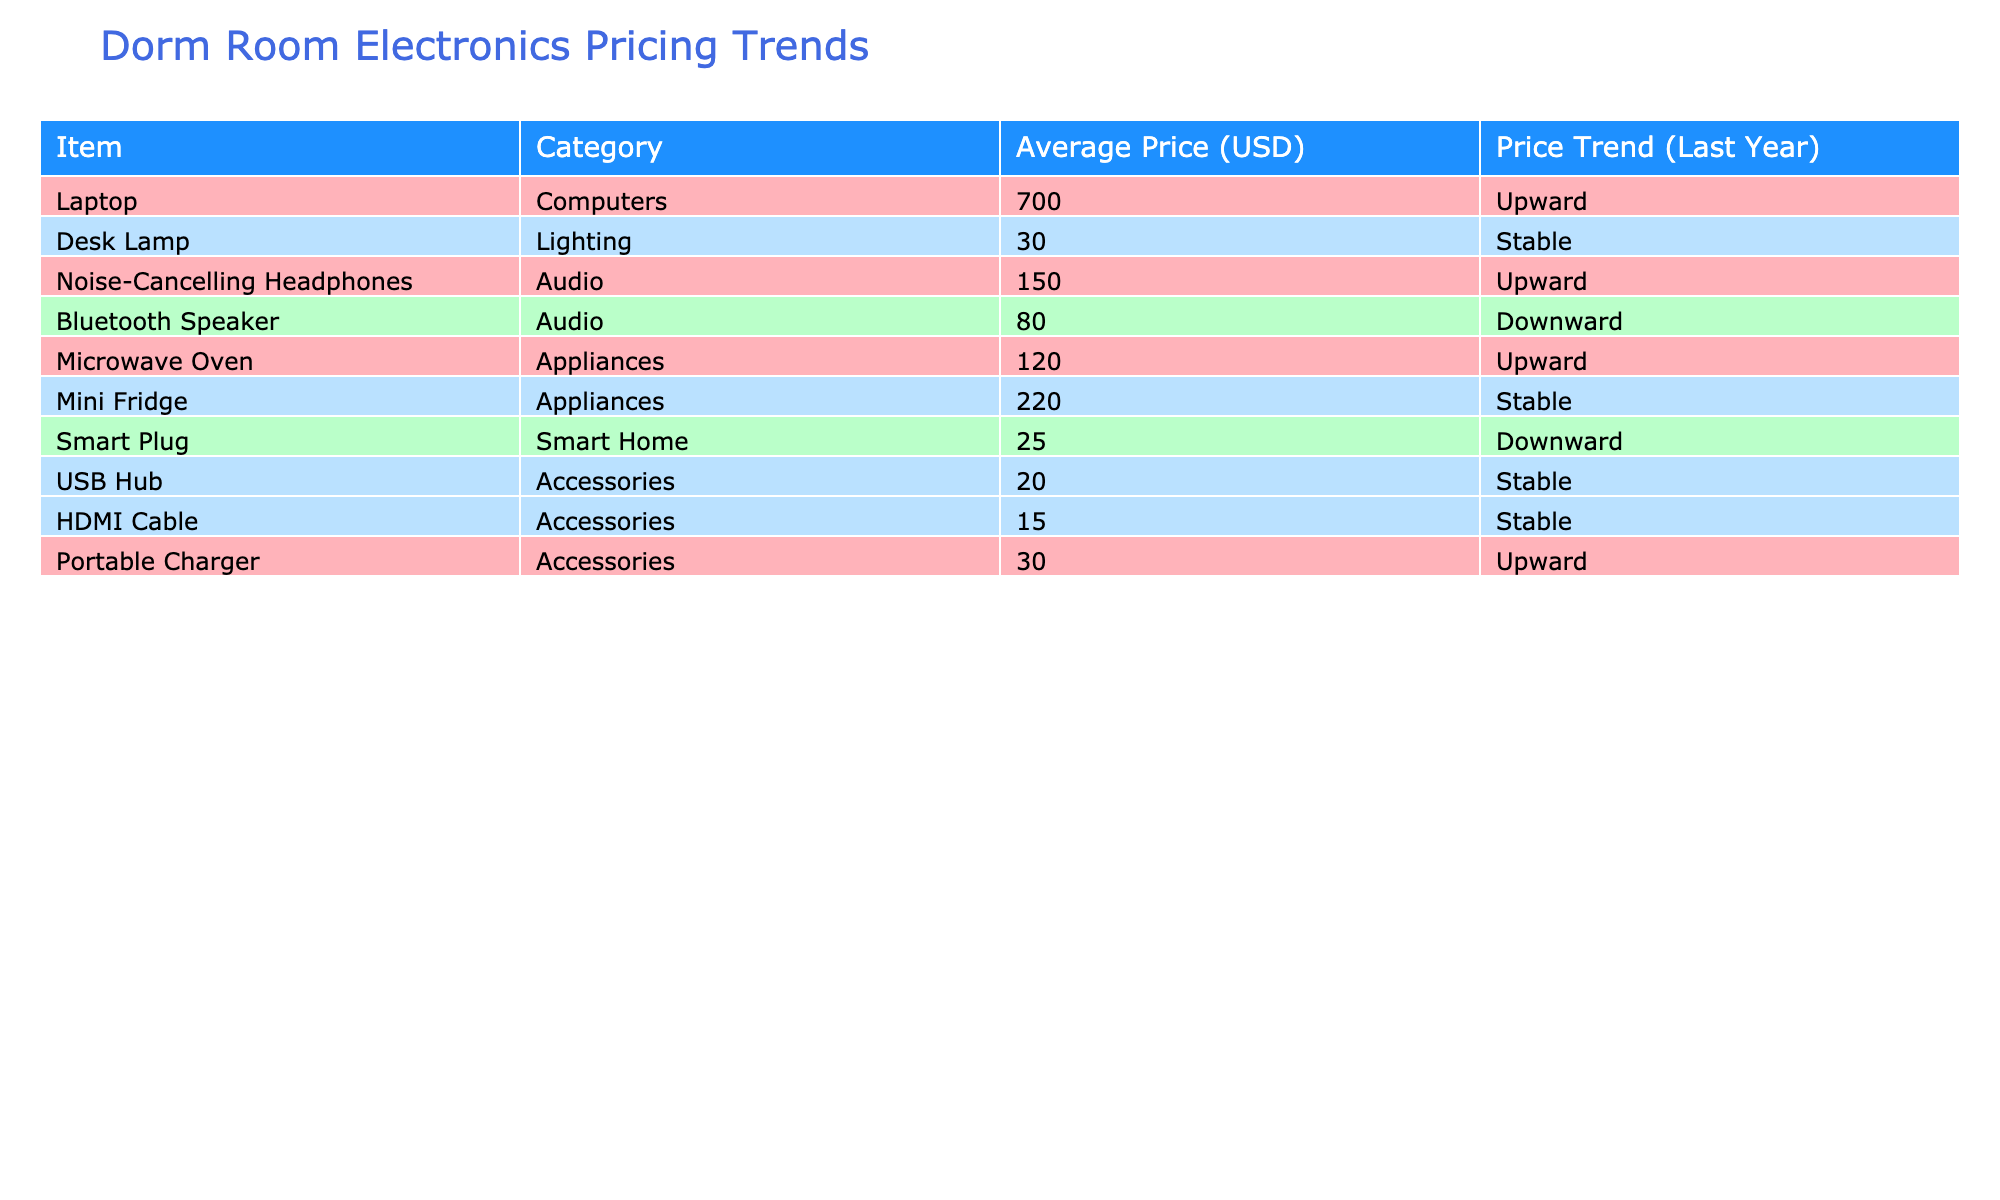What is the average price of laptops in the table? The average price of laptops listed in the table is 700.00 USD as shown in the relevant row under the Average Price column.
Answer: 700.00 USD Which items have a downward price trend? Reviewing the Price Trend column in the table, the items with a downward trend are the Bluetooth Speaker and the Smart Plug.
Answer: Bluetooth Speaker, Smart Plug What is the difference between the average price of the Mini Fridge and the Microwave Oven? The average price of the Mini Fridge is 220.00 USD and that of the Microwave Oven is 120.00 USD. To find the difference, subtract 120.00 USD from 220.00 USD, which equals 100.00 USD.
Answer: 100.00 USD Are Noise-Cancelling Headphones more expensive than Noise-Cancelling Speakers? Since Noise-Cancelling Speakers are not listed in the table, this question is based on limited information. However, since the Noise-Cancelling Headphones’ price is 150.00 USD and there is no price mentioned for Noise-Cancelling Speakers, we cannot conclusively compare the two.
Answer: No What is the average price of items in the Audio category? The items in the Audio category are Noise-Cancelling Headphones at 150.00 USD and Bluetooth Speaker at 80.00 USD. First, sum the prices: 150.00 + 80.00 = 230.00 USD. There are two items, so dividing 230.00 USD by 2 gives an average price of 115.00 USD.
Answer: 115.00 USD Is the price of the Desk Lamp higher than the average price of all appliances? The Desk Lamp costs 30.00 USD. The average price for the appliances (Microwave Oven and Mini Fridge) can be calculated by summing their prices: 120.00 + 220.00 = 340.00 USD, then dividing by 2 gives an average of 170.00 USD. Since 30.00 USD is not higher than 170.00 USD, the answer is no.
Answer: No How many items experienced a stable price trend? Looking at the Price Trend column, the items with a stable trend are Desk Lamp, Mini Fridge, USB Hub, and HDMI Cable. Counting these gives a total of four items with stable prices.
Answer: 4 items What is the total average price for Accessories? The Accessories category includes Portable Charger (30.00 USD), USB Hub (20.00 USD), and HDMI Cable (15.00 USD). Summing these prices gives 30.00 + 20.00 + 15.00 = 65.00 USD. There are three items, so the average is 65.00 USD divided by 3, equals approximately 21.67 USD.
Answer: 21.67 USD 